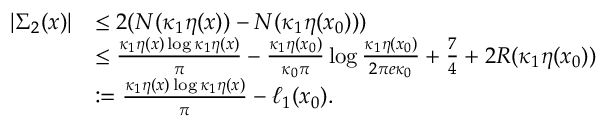<formula> <loc_0><loc_0><loc_500><loc_500>\begin{array} { r l } { | \Sigma _ { 2 } ( x ) | } & { \leq 2 ( N ( \kappa _ { 1 } \eta ( x ) ) - N ( \kappa _ { 1 } \eta ( x _ { 0 } ) ) ) } \\ & { \leq \frac { \kappa _ { 1 } \eta ( x ) \log { \kappa _ { 1 } \eta ( x ) } } { \pi } - \frac { \kappa _ { 1 } \eta ( x _ { 0 } ) } { \kappa _ { 0 } \pi } \log { \frac { \kappa _ { 1 } \eta ( x _ { 0 } ) } { 2 \pi e \kappa _ { 0 } } } + \frac { 7 } { 4 } + 2 R ( \kappa _ { 1 } \eta ( x _ { 0 } ) ) } \\ & { \colon = \frac { \kappa _ { 1 } \eta ( x ) \log { \kappa _ { 1 } \eta ( x ) } } { \pi } - \ell _ { 1 } ( x _ { 0 } ) . } \end{array}</formula> 